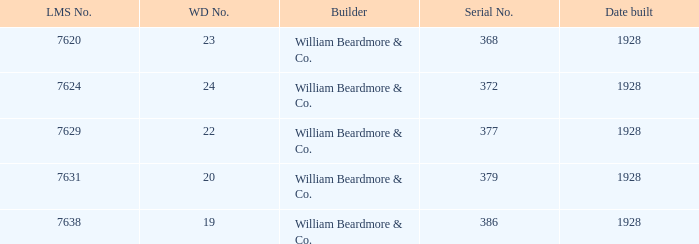Provide the lms value corresponding to the serial number 37 7624.0. 